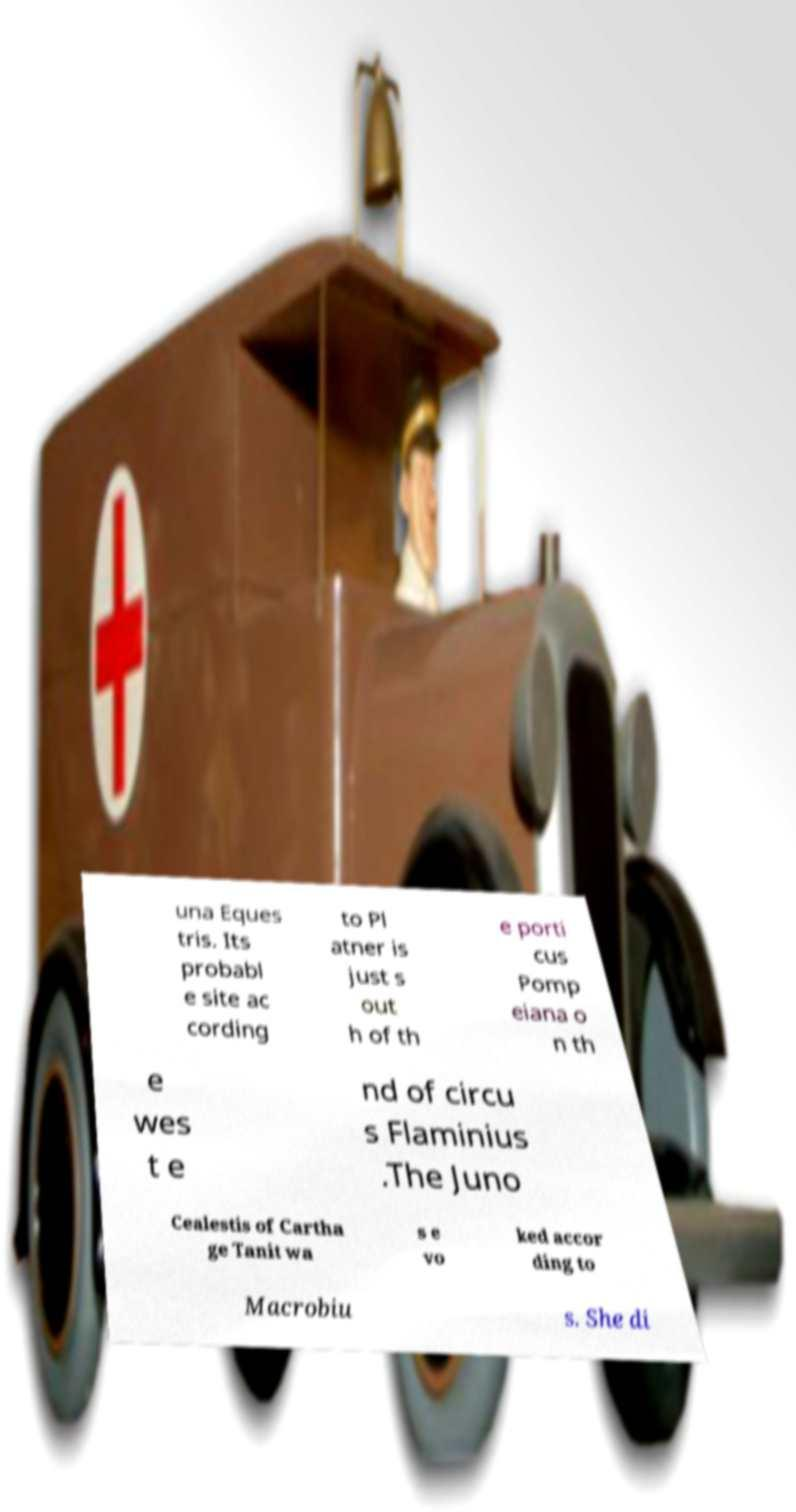I need the written content from this picture converted into text. Can you do that? una Eques tris. Its probabl e site ac cording to Pl atner is just s out h of th e porti cus Pomp eiana o n th e wes t e nd of circu s Flaminius .The Juno Cealestis of Cartha ge Tanit wa s e vo ked accor ding to Macrobiu s. She di 